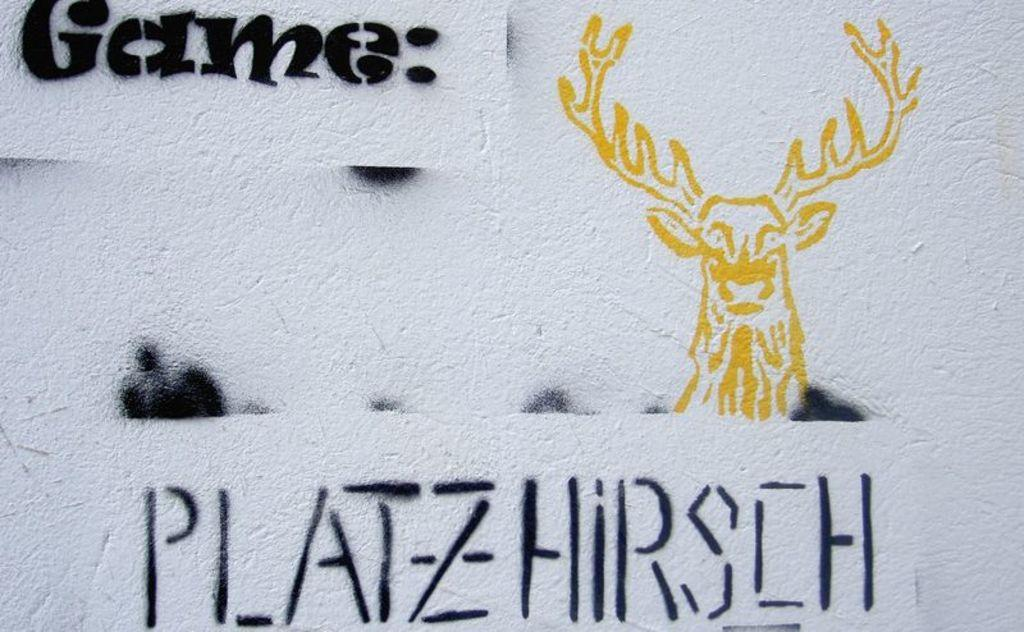What type of object in the image resembles a wall? There is an object in the image that resembles a wall. What can be found on the wall in the image? The wall contains text and a depiction of an animal. What type of animal is depicted on the wall? The depicted animal is a deer. What type of pan can be seen hanging on the wall in the image? There is no pan present in the image. 